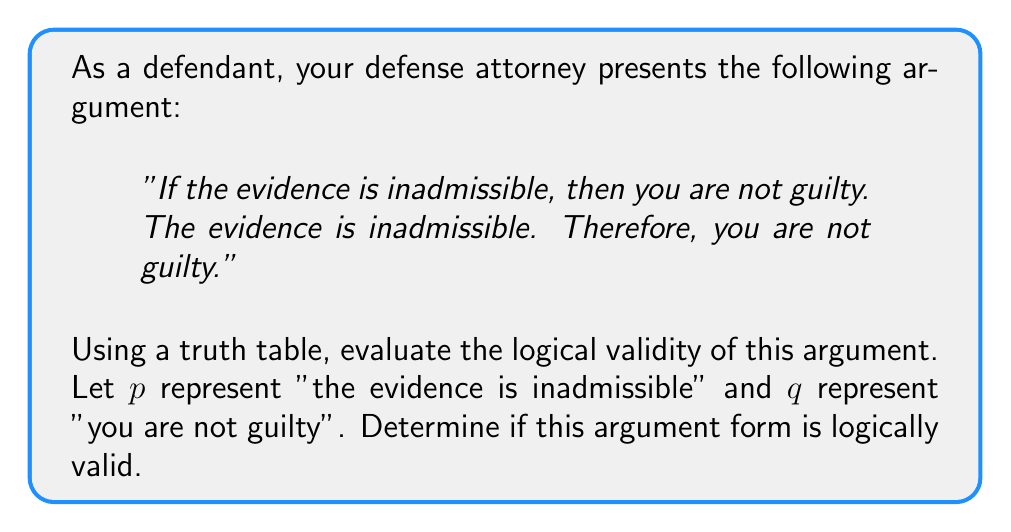Provide a solution to this math problem. To evaluate the logical validity of this argument, we need to construct a truth table and analyze the logical form. The argument has the following structure:

1. $p \rightarrow q$ (If the evidence is inadmissible, then you are not guilty)
2. $p$ (The evidence is inadmissible)
3. Therefore, $q$ (You are not guilty)

This argument form is known as Modus Ponens.

Let's construct the truth table:

$$
\begin{array}{|c|c|c|c|c|}
\hline
p & q & p \rightarrow q & p & q \\
\hline
T & T & T & T & T \\
T & F & F & T & F \\
F & T & T & F & T \\
F & F & T & F & F \\
\hline
\end{array}
$$

To determine if the argument is logically valid, we need to check if there's any row where all premises are true (columns 3 and 4) but the conclusion is false (column 5).

In this case:
1. When $p$ is true and $q$ is true (first row), all premises are true, and the conclusion is true.
2. When $p$ is true and $q$ is false (second row), the first premise $(p \rightarrow q)$ is false.
3. When $p$ is false (third and fourth rows), the second premise is false.

There is no row where all premises are true and the conclusion is false. Therefore, this argument form (Modus Ponens) is logically valid.
Answer: The argument is logically valid. 